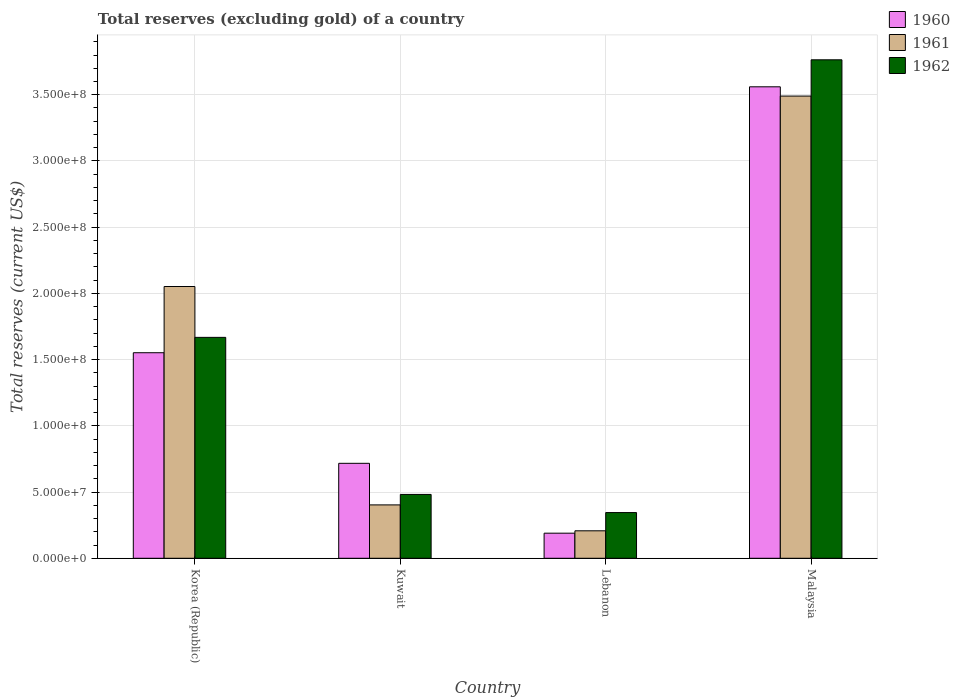Are the number of bars per tick equal to the number of legend labels?
Keep it short and to the point. Yes. What is the label of the 1st group of bars from the left?
Offer a terse response. Korea (Republic). In how many cases, is the number of bars for a given country not equal to the number of legend labels?
Your response must be concise. 0. What is the total reserves (excluding gold) in 1960 in Korea (Republic)?
Offer a terse response. 1.55e+08. Across all countries, what is the maximum total reserves (excluding gold) in 1960?
Ensure brevity in your answer.  3.56e+08. Across all countries, what is the minimum total reserves (excluding gold) in 1962?
Ensure brevity in your answer.  3.45e+07. In which country was the total reserves (excluding gold) in 1962 maximum?
Offer a very short reply. Malaysia. In which country was the total reserves (excluding gold) in 1961 minimum?
Ensure brevity in your answer.  Lebanon. What is the total total reserves (excluding gold) in 1962 in the graph?
Provide a succinct answer. 6.26e+08. What is the difference between the total reserves (excluding gold) in 1962 in Korea (Republic) and that in Lebanon?
Give a very brief answer. 1.32e+08. What is the difference between the total reserves (excluding gold) in 1960 in Kuwait and the total reserves (excluding gold) in 1962 in Korea (Republic)?
Provide a succinct answer. -9.51e+07. What is the average total reserves (excluding gold) in 1961 per country?
Keep it short and to the point. 1.54e+08. What is the difference between the total reserves (excluding gold) of/in 1961 and total reserves (excluding gold) of/in 1960 in Lebanon?
Keep it short and to the point. 1.80e+06. What is the ratio of the total reserves (excluding gold) in 1962 in Korea (Republic) to that in Malaysia?
Your answer should be compact. 0.44. Is the total reserves (excluding gold) in 1962 in Kuwait less than that in Malaysia?
Offer a very short reply. Yes. What is the difference between the highest and the second highest total reserves (excluding gold) in 1962?
Provide a succinct answer. 1.19e+08. What is the difference between the highest and the lowest total reserves (excluding gold) in 1962?
Keep it short and to the point. 3.42e+08. Is the sum of the total reserves (excluding gold) in 1962 in Kuwait and Lebanon greater than the maximum total reserves (excluding gold) in 1961 across all countries?
Your answer should be compact. No. How many bars are there?
Ensure brevity in your answer.  12. Are all the bars in the graph horizontal?
Your answer should be compact. No. What is the difference between two consecutive major ticks on the Y-axis?
Ensure brevity in your answer.  5.00e+07. Does the graph contain grids?
Offer a very short reply. Yes. How many legend labels are there?
Your answer should be very brief. 3. What is the title of the graph?
Your answer should be compact. Total reserves (excluding gold) of a country. What is the label or title of the Y-axis?
Ensure brevity in your answer.  Total reserves (current US$). What is the Total reserves (current US$) of 1960 in Korea (Republic)?
Provide a succinct answer. 1.55e+08. What is the Total reserves (current US$) in 1961 in Korea (Republic)?
Make the answer very short. 2.05e+08. What is the Total reserves (current US$) in 1962 in Korea (Republic)?
Keep it short and to the point. 1.67e+08. What is the Total reserves (current US$) in 1960 in Kuwait?
Provide a short and direct response. 7.17e+07. What is the Total reserves (current US$) of 1961 in Kuwait?
Provide a succinct answer. 4.03e+07. What is the Total reserves (current US$) of 1962 in Kuwait?
Make the answer very short. 4.82e+07. What is the Total reserves (current US$) of 1960 in Lebanon?
Offer a very short reply. 1.89e+07. What is the Total reserves (current US$) in 1961 in Lebanon?
Your answer should be very brief. 2.07e+07. What is the Total reserves (current US$) of 1962 in Lebanon?
Your answer should be very brief. 3.45e+07. What is the Total reserves (current US$) of 1960 in Malaysia?
Offer a very short reply. 3.56e+08. What is the Total reserves (current US$) in 1961 in Malaysia?
Your answer should be very brief. 3.49e+08. What is the Total reserves (current US$) of 1962 in Malaysia?
Give a very brief answer. 3.76e+08. Across all countries, what is the maximum Total reserves (current US$) in 1960?
Make the answer very short. 3.56e+08. Across all countries, what is the maximum Total reserves (current US$) in 1961?
Your response must be concise. 3.49e+08. Across all countries, what is the maximum Total reserves (current US$) of 1962?
Give a very brief answer. 3.76e+08. Across all countries, what is the minimum Total reserves (current US$) in 1960?
Give a very brief answer. 1.89e+07. Across all countries, what is the minimum Total reserves (current US$) of 1961?
Provide a short and direct response. 2.07e+07. Across all countries, what is the minimum Total reserves (current US$) of 1962?
Provide a succinct answer. 3.45e+07. What is the total Total reserves (current US$) of 1960 in the graph?
Offer a very short reply. 6.02e+08. What is the total Total reserves (current US$) in 1961 in the graph?
Ensure brevity in your answer.  6.15e+08. What is the total Total reserves (current US$) of 1962 in the graph?
Provide a succinct answer. 6.26e+08. What is the difference between the Total reserves (current US$) in 1960 in Korea (Republic) and that in Kuwait?
Offer a terse response. 8.35e+07. What is the difference between the Total reserves (current US$) in 1961 in Korea (Republic) and that in Kuwait?
Make the answer very short. 1.65e+08. What is the difference between the Total reserves (current US$) in 1962 in Korea (Republic) and that in Kuwait?
Keep it short and to the point. 1.19e+08. What is the difference between the Total reserves (current US$) in 1960 in Korea (Republic) and that in Lebanon?
Provide a succinct answer. 1.36e+08. What is the difference between the Total reserves (current US$) in 1961 in Korea (Republic) and that in Lebanon?
Offer a very short reply. 1.84e+08. What is the difference between the Total reserves (current US$) of 1962 in Korea (Republic) and that in Lebanon?
Keep it short and to the point. 1.32e+08. What is the difference between the Total reserves (current US$) of 1960 in Korea (Republic) and that in Malaysia?
Your answer should be very brief. -2.01e+08. What is the difference between the Total reserves (current US$) in 1961 in Korea (Republic) and that in Malaysia?
Offer a very short reply. -1.44e+08. What is the difference between the Total reserves (current US$) in 1962 in Korea (Republic) and that in Malaysia?
Make the answer very short. -2.10e+08. What is the difference between the Total reserves (current US$) of 1960 in Kuwait and that in Lebanon?
Keep it short and to the point. 5.28e+07. What is the difference between the Total reserves (current US$) of 1961 in Kuwait and that in Lebanon?
Ensure brevity in your answer.  1.96e+07. What is the difference between the Total reserves (current US$) of 1962 in Kuwait and that in Lebanon?
Offer a very short reply. 1.37e+07. What is the difference between the Total reserves (current US$) in 1960 in Kuwait and that in Malaysia?
Your answer should be very brief. -2.84e+08. What is the difference between the Total reserves (current US$) of 1961 in Kuwait and that in Malaysia?
Keep it short and to the point. -3.09e+08. What is the difference between the Total reserves (current US$) in 1962 in Kuwait and that in Malaysia?
Provide a short and direct response. -3.28e+08. What is the difference between the Total reserves (current US$) in 1960 in Lebanon and that in Malaysia?
Keep it short and to the point. -3.37e+08. What is the difference between the Total reserves (current US$) in 1961 in Lebanon and that in Malaysia?
Give a very brief answer. -3.28e+08. What is the difference between the Total reserves (current US$) of 1962 in Lebanon and that in Malaysia?
Provide a succinct answer. -3.42e+08. What is the difference between the Total reserves (current US$) of 1960 in Korea (Republic) and the Total reserves (current US$) of 1961 in Kuwait?
Provide a short and direct response. 1.15e+08. What is the difference between the Total reserves (current US$) in 1960 in Korea (Republic) and the Total reserves (current US$) in 1962 in Kuwait?
Keep it short and to the point. 1.07e+08. What is the difference between the Total reserves (current US$) of 1961 in Korea (Republic) and the Total reserves (current US$) of 1962 in Kuwait?
Your response must be concise. 1.57e+08. What is the difference between the Total reserves (current US$) in 1960 in Korea (Republic) and the Total reserves (current US$) in 1961 in Lebanon?
Give a very brief answer. 1.34e+08. What is the difference between the Total reserves (current US$) of 1960 in Korea (Republic) and the Total reserves (current US$) of 1962 in Lebanon?
Your response must be concise. 1.21e+08. What is the difference between the Total reserves (current US$) in 1961 in Korea (Republic) and the Total reserves (current US$) in 1962 in Lebanon?
Offer a terse response. 1.71e+08. What is the difference between the Total reserves (current US$) of 1960 in Korea (Republic) and the Total reserves (current US$) of 1961 in Malaysia?
Offer a terse response. -1.94e+08. What is the difference between the Total reserves (current US$) in 1960 in Korea (Republic) and the Total reserves (current US$) in 1962 in Malaysia?
Give a very brief answer. -2.21e+08. What is the difference between the Total reserves (current US$) of 1961 in Korea (Republic) and the Total reserves (current US$) of 1962 in Malaysia?
Your answer should be compact. -1.71e+08. What is the difference between the Total reserves (current US$) in 1960 in Kuwait and the Total reserves (current US$) in 1961 in Lebanon?
Your answer should be very brief. 5.10e+07. What is the difference between the Total reserves (current US$) of 1960 in Kuwait and the Total reserves (current US$) of 1962 in Lebanon?
Your response must be concise. 3.72e+07. What is the difference between the Total reserves (current US$) in 1961 in Kuwait and the Total reserves (current US$) in 1962 in Lebanon?
Keep it short and to the point. 5.79e+06. What is the difference between the Total reserves (current US$) in 1960 in Kuwait and the Total reserves (current US$) in 1961 in Malaysia?
Provide a short and direct response. -2.77e+08. What is the difference between the Total reserves (current US$) of 1960 in Kuwait and the Total reserves (current US$) of 1962 in Malaysia?
Offer a terse response. -3.05e+08. What is the difference between the Total reserves (current US$) in 1961 in Kuwait and the Total reserves (current US$) in 1962 in Malaysia?
Provide a succinct answer. -3.36e+08. What is the difference between the Total reserves (current US$) in 1960 in Lebanon and the Total reserves (current US$) in 1961 in Malaysia?
Your answer should be very brief. -3.30e+08. What is the difference between the Total reserves (current US$) of 1960 in Lebanon and the Total reserves (current US$) of 1962 in Malaysia?
Your response must be concise. -3.57e+08. What is the difference between the Total reserves (current US$) of 1961 in Lebanon and the Total reserves (current US$) of 1962 in Malaysia?
Provide a succinct answer. -3.56e+08. What is the average Total reserves (current US$) of 1960 per country?
Make the answer very short. 1.50e+08. What is the average Total reserves (current US$) of 1961 per country?
Provide a succinct answer. 1.54e+08. What is the average Total reserves (current US$) in 1962 per country?
Your answer should be very brief. 1.56e+08. What is the difference between the Total reserves (current US$) of 1960 and Total reserves (current US$) of 1961 in Korea (Republic)?
Provide a succinct answer. -5.00e+07. What is the difference between the Total reserves (current US$) in 1960 and Total reserves (current US$) in 1962 in Korea (Republic)?
Provide a succinct answer. -1.16e+07. What is the difference between the Total reserves (current US$) in 1961 and Total reserves (current US$) in 1962 in Korea (Republic)?
Provide a short and direct response. 3.84e+07. What is the difference between the Total reserves (current US$) in 1960 and Total reserves (current US$) in 1961 in Kuwait?
Your answer should be compact. 3.14e+07. What is the difference between the Total reserves (current US$) of 1960 and Total reserves (current US$) of 1962 in Kuwait?
Make the answer very short. 2.35e+07. What is the difference between the Total reserves (current US$) in 1961 and Total reserves (current US$) in 1962 in Kuwait?
Ensure brevity in your answer.  -7.90e+06. What is the difference between the Total reserves (current US$) of 1960 and Total reserves (current US$) of 1961 in Lebanon?
Provide a short and direct response. -1.80e+06. What is the difference between the Total reserves (current US$) in 1960 and Total reserves (current US$) in 1962 in Lebanon?
Provide a short and direct response. -1.56e+07. What is the difference between the Total reserves (current US$) of 1961 and Total reserves (current US$) of 1962 in Lebanon?
Provide a short and direct response. -1.38e+07. What is the difference between the Total reserves (current US$) of 1960 and Total reserves (current US$) of 1962 in Malaysia?
Offer a very short reply. -2.04e+07. What is the difference between the Total reserves (current US$) of 1961 and Total reserves (current US$) of 1962 in Malaysia?
Your answer should be compact. -2.74e+07. What is the ratio of the Total reserves (current US$) in 1960 in Korea (Republic) to that in Kuwait?
Your answer should be very brief. 2.16. What is the ratio of the Total reserves (current US$) in 1961 in Korea (Republic) to that in Kuwait?
Offer a terse response. 5.09. What is the ratio of the Total reserves (current US$) of 1962 in Korea (Republic) to that in Kuwait?
Ensure brevity in your answer.  3.46. What is the ratio of the Total reserves (current US$) in 1960 in Korea (Republic) to that in Lebanon?
Offer a very short reply. 8.19. What is the ratio of the Total reserves (current US$) in 1961 in Korea (Republic) to that in Lebanon?
Provide a short and direct response. 9.89. What is the ratio of the Total reserves (current US$) in 1962 in Korea (Republic) to that in Lebanon?
Your answer should be very brief. 4.83. What is the ratio of the Total reserves (current US$) of 1960 in Korea (Republic) to that in Malaysia?
Ensure brevity in your answer.  0.44. What is the ratio of the Total reserves (current US$) in 1961 in Korea (Republic) to that in Malaysia?
Your response must be concise. 0.59. What is the ratio of the Total reserves (current US$) of 1962 in Korea (Republic) to that in Malaysia?
Give a very brief answer. 0.44. What is the ratio of the Total reserves (current US$) in 1960 in Kuwait to that in Lebanon?
Offer a terse response. 3.79. What is the ratio of the Total reserves (current US$) of 1961 in Kuwait to that in Lebanon?
Offer a terse response. 1.94. What is the ratio of the Total reserves (current US$) in 1962 in Kuwait to that in Lebanon?
Offer a terse response. 1.4. What is the ratio of the Total reserves (current US$) of 1960 in Kuwait to that in Malaysia?
Your answer should be very brief. 0.2. What is the ratio of the Total reserves (current US$) of 1961 in Kuwait to that in Malaysia?
Offer a very short reply. 0.12. What is the ratio of the Total reserves (current US$) of 1962 in Kuwait to that in Malaysia?
Keep it short and to the point. 0.13. What is the ratio of the Total reserves (current US$) of 1960 in Lebanon to that in Malaysia?
Keep it short and to the point. 0.05. What is the ratio of the Total reserves (current US$) in 1961 in Lebanon to that in Malaysia?
Your answer should be very brief. 0.06. What is the ratio of the Total reserves (current US$) of 1962 in Lebanon to that in Malaysia?
Your answer should be very brief. 0.09. What is the difference between the highest and the second highest Total reserves (current US$) in 1960?
Your answer should be very brief. 2.01e+08. What is the difference between the highest and the second highest Total reserves (current US$) in 1961?
Your response must be concise. 1.44e+08. What is the difference between the highest and the second highest Total reserves (current US$) in 1962?
Offer a very short reply. 2.10e+08. What is the difference between the highest and the lowest Total reserves (current US$) of 1960?
Your answer should be very brief. 3.37e+08. What is the difference between the highest and the lowest Total reserves (current US$) of 1961?
Provide a succinct answer. 3.28e+08. What is the difference between the highest and the lowest Total reserves (current US$) in 1962?
Keep it short and to the point. 3.42e+08. 